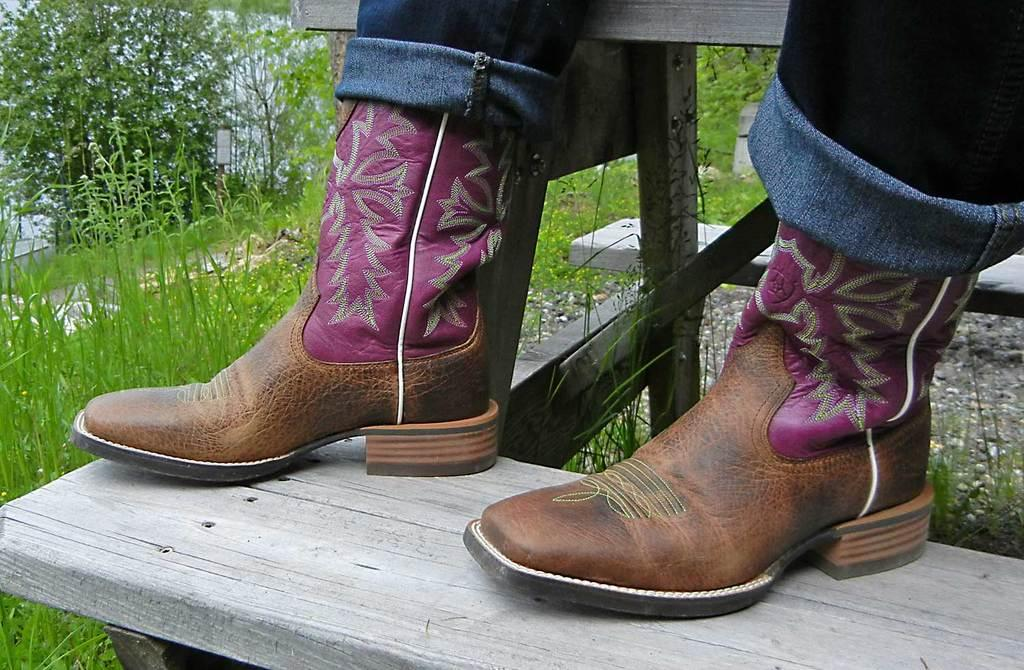What is the main subject of the image? There is a person in the image. What part of the person's body is visible in the center of the image? The person's legs are visible in the center of the image. What type of surface is the person standing on? The person is on wooden stairs. What can be seen in the background of the image? There are plants and grass in the background of the image. How many boys are singing in the image? There are no boys or singing depicted in the image; it features a person standing on wooden stairs with plants and grass in the background. 